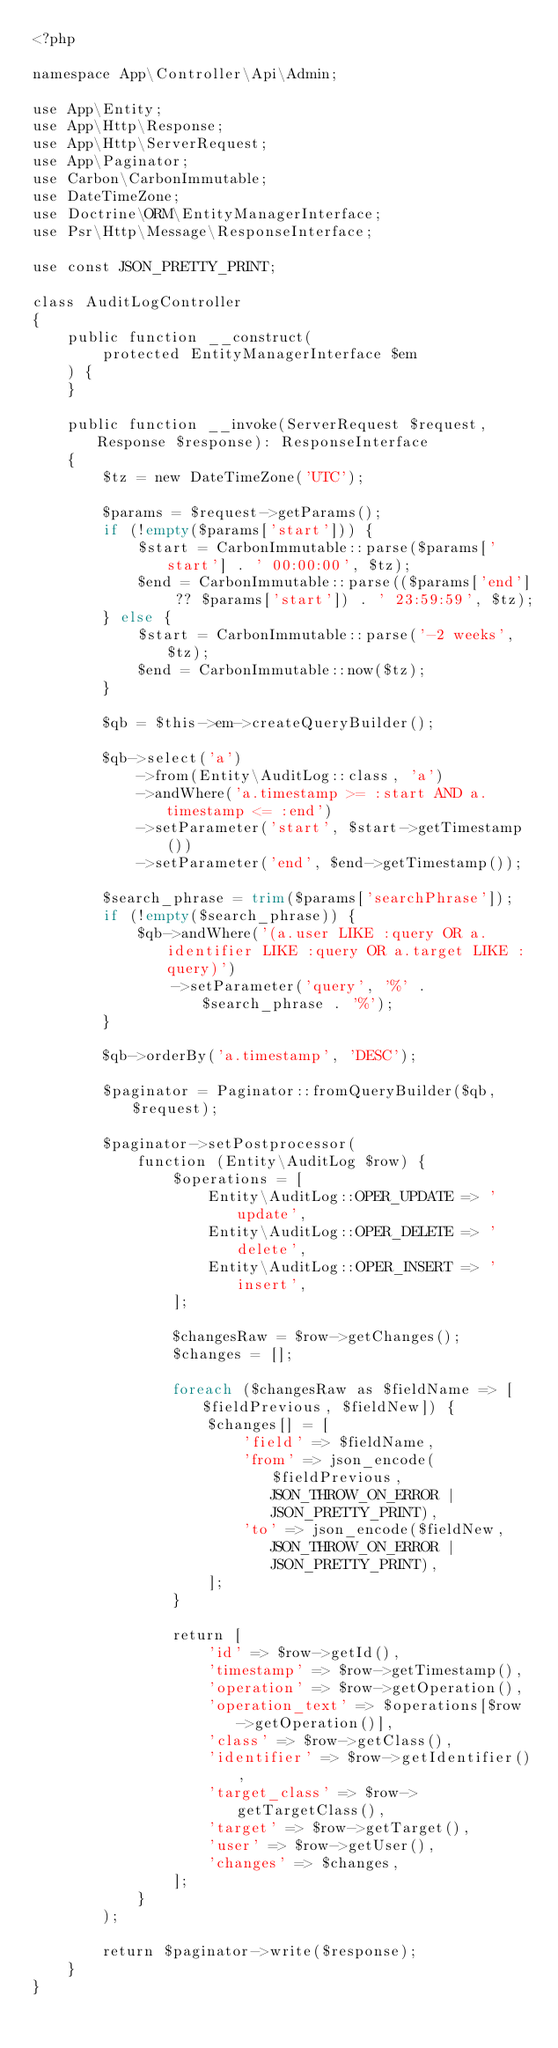<code> <loc_0><loc_0><loc_500><loc_500><_PHP_><?php

namespace App\Controller\Api\Admin;

use App\Entity;
use App\Http\Response;
use App\Http\ServerRequest;
use App\Paginator;
use Carbon\CarbonImmutable;
use DateTimeZone;
use Doctrine\ORM\EntityManagerInterface;
use Psr\Http\Message\ResponseInterface;

use const JSON_PRETTY_PRINT;

class AuditLogController
{
    public function __construct(
        protected EntityManagerInterface $em
    ) {
    }

    public function __invoke(ServerRequest $request, Response $response): ResponseInterface
    {
        $tz = new DateTimeZone('UTC');

        $params = $request->getParams();
        if (!empty($params['start'])) {
            $start = CarbonImmutable::parse($params['start'] . ' 00:00:00', $tz);
            $end = CarbonImmutable::parse(($params['end'] ?? $params['start']) . ' 23:59:59', $tz);
        } else {
            $start = CarbonImmutable::parse('-2 weeks', $tz);
            $end = CarbonImmutable::now($tz);
        }

        $qb = $this->em->createQueryBuilder();

        $qb->select('a')
            ->from(Entity\AuditLog::class, 'a')
            ->andWhere('a.timestamp >= :start AND a.timestamp <= :end')
            ->setParameter('start', $start->getTimestamp())
            ->setParameter('end', $end->getTimestamp());

        $search_phrase = trim($params['searchPhrase']);
        if (!empty($search_phrase)) {
            $qb->andWhere('(a.user LIKE :query OR a.identifier LIKE :query OR a.target LIKE :query)')
                ->setParameter('query', '%' . $search_phrase . '%');
        }

        $qb->orderBy('a.timestamp', 'DESC');

        $paginator = Paginator::fromQueryBuilder($qb, $request);

        $paginator->setPostprocessor(
            function (Entity\AuditLog $row) {
                $operations = [
                    Entity\AuditLog::OPER_UPDATE => 'update',
                    Entity\AuditLog::OPER_DELETE => 'delete',
                    Entity\AuditLog::OPER_INSERT => 'insert',
                ];

                $changesRaw = $row->getChanges();
                $changes = [];

                foreach ($changesRaw as $fieldName => [$fieldPrevious, $fieldNew]) {
                    $changes[] = [
                        'field' => $fieldName,
                        'from' => json_encode($fieldPrevious, JSON_THROW_ON_ERROR | JSON_PRETTY_PRINT),
                        'to' => json_encode($fieldNew, JSON_THROW_ON_ERROR | JSON_PRETTY_PRINT),
                    ];
                }

                return [
                    'id' => $row->getId(),
                    'timestamp' => $row->getTimestamp(),
                    'operation' => $row->getOperation(),
                    'operation_text' => $operations[$row->getOperation()],
                    'class' => $row->getClass(),
                    'identifier' => $row->getIdentifier(),
                    'target_class' => $row->getTargetClass(),
                    'target' => $row->getTarget(),
                    'user' => $row->getUser(),
                    'changes' => $changes,
                ];
            }
        );

        return $paginator->write($response);
    }
}
</code> 